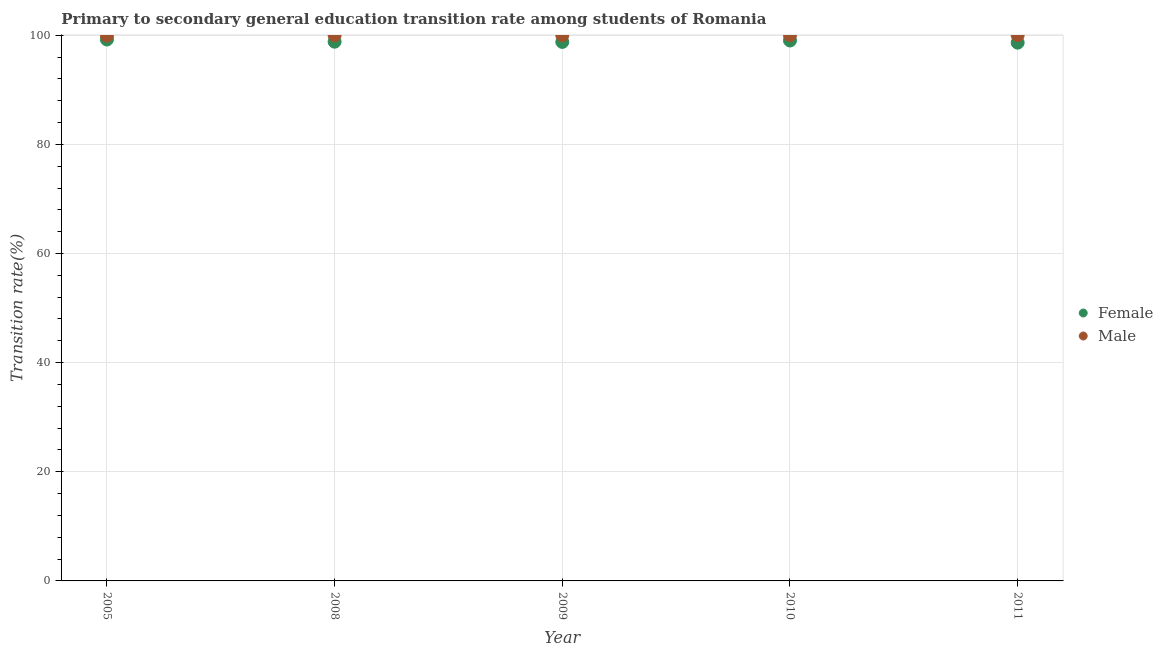How many different coloured dotlines are there?
Your answer should be very brief. 2. Across all years, what is the minimum transition rate among female students?
Your answer should be compact. 98.64. In which year was the transition rate among male students maximum?
Provide a short and direct response. 2008. What is the total transition rate among male students in the graph?
Provide a short and direct response. 499.93. What is the difference between the transition rate among female students in 2008 and that in 2011?
Provide a succinct answer. 0.18. What is the difference between the transition rate among female students in 2011 and the transition rate among male students in 2009?
Your answer should be very brief. -1.36. What is the average transition rate among male students per year?
Your response must be concise. 99.99. In the year 2011, what is the difference between the transition rate among male students and transition rate among female students?
Offer a very short reply. 1.36. In how many years, is the transition rate among female students greater than 16 %?
Make the answer very short. 5. What is the ratio of the transition rate among male students in 2005 to that in 2008?
Give a very brief answer. 1. Is the transition rate among male students in 2005 less than that in 2011?
Make the answer very short. Yes. What is the difference between the highest and the lowest transition rate among male students?
Make the answer very short. 0.07. In how many years, is the transition rate among female students greater than the average transition rate among female students taken over all years?
Your answer should be very brief. 2. Is the sum of the transition rate among male students in 2005 and 2008 greater than the maximum transition rate among female students across all years?
Offer a terse response. Yes. Is the transition rate among female students strictly greater than the transition rate among male students over the years?
Your answer should be compact. No. Is the transition rate among female students strictly less than the transition rate among male students over the years?
Keep it short and to the point. Yes. How many dotlines are there?
Offer a terse response. 2. What is the difference between two consecutive major ticks on the Y-axis?
Offer a terse response. 20. Where does the legend appear in the graph?
Your response must be concise. Center right. How are the legend labels stacked?
Provide a succinct answer. Vertical. What is the title of the graph?
Ensure brevity in your answer.  Primary to secondary general education transition rate among students of Romania. What is the label or title of the X-axis?
Ensure brevity in your answer.  Year. What is the label or title of the Y-axis?
Offer a very short reply. Transition rate(%). What is the Transition rate(%) of Female in 2005?
Your answer should be very brief. 99.22. What is the Transition rate(%) of Male in 2005?
Your answer should be very brief. 99.93. What is the Transition rate(%) of Female in 2008?
Make the answer very short. 98.82. What is the Transition rate(%) of Female in 2009?
Your response must be concise. 98.78. What is the Transition rate(%) of Male in 2009?
Your answer should be very brief. 100. What is the Transition rate(%) in Female in 2010?
Offer a terse response. 99.04. What is the Transition rate(%) in Male in 2010?
Offer a terse response. 100. What is the Transition rate(%) in Female in 2011?
Your response must be concise. 98.64. What is the Transition rate(%) in Male in 2011?
Provide a succinct answer. 100. Across all years, what is the maximum Transition rate(%) of Female?
Offer a terse response. 99.22. Across all years, what is the maximum Transition rate(%) in Male?
Your answer should be compact. 100. Across all years, what is the minimum Transition rate(%) in Female?
Your response must be concise. 98.64. Across all years, what is the minimum Transition rate(%) in Male?
Offer a very short reply. 99.93. What is the total Transition rate(%) in Female in the graph?
Your answer should be compact. 494.51. What is the total Transition rate(%) in Male in the graph?
Offer a very short reply. 499.93. What is the difference between the Transition rate(%) in Female in 2005 and that in 2008?
Your answer should be very brief. 0.4. What is the difference between the Transition rate(%) in Male in 2005 and that in 2008?
Provide a short and direct response. -0.07. What is the difference between the Transition rate(%) in Female in 2005 and that in 2009?
Your answer should be very brief. 0.44. What is the difference between the Transition rate(%) in Male in 2005 and that in 2009?
Offer a very short reply. -0.07. What is the difference between the Transition rate(%) in Female in 2005 and that in 2010?
Your response must be concise. 0.18. What is the difference between the Transition rate(%) of Male in 2005 and that in 2010?
Offer a very short reply. -0.07. What is the difference between the Transition rate(%) of Female in 2005 and that in 2011?
Make the answer very short. 0.58. What is the difference between the Transition rate(%) in Male in 2005 and that in 2011?
Make the answer very short. -0.07. What is the difference between the Transition rate(%) in Female in 2008 and that in 2009?
Give a very brief answer. 0.04. What is the difference between the Transition rate(%) in Female in 2008 and that in 2010?
Your answer should be compact. -0.22. What is the difference between the Transition rate(%) of Female in 2008 and that in 2011?
Offer a very short reply. 0.18. What is the difference between the Transition rate(%) of Male in 2008 and that in 2011?
Ensure brevity in your answer.  0. What is the difference between the Transition rate(%) of Female in 2009 and that in 2010?
Offer a very short reply. -0.26. What is the difference between the Transition rate(%) in Male in 2009 and that in 2010?
Your answer should be compact. 0. What is the difference between the Transition rate(%) of Female in 2009 and that in 2011?
Your answer should be compact. 0.13. What is the difference between the Transition rate(%) in Female in 2010 and that in 2011?
Your response must be concise. 0.39. What is the difference between the Transition rate(%) of Female in 2005 and the Transition rate(%) of Male in 2008?
Your response must be concise. -0.78. What is the difference between the Transition rate(%) of Female in 2005 and the Transition rate(%) of Male in 2009?
Offer a very short reply. -0.78. What is the difference between the Transition rate(%) in Female in 2005 and the Transition rate(%) in Male in 2010?
Keep it short and to the point. -0.78. What is the difference between the Transition rate(%) in Female in 2005 and the Transition rate(%) in Male in 2011?
Offer a terse response. -0.78. What is the difference between the Transition rate(%) in Female in 2008 and the Transition rate(%) in Male in 2009?
Offer a very short reply. -1.18. What is the difference between the Transition rate(%) of Female in 2008 and the Transition rate(%) of Male in 2010?
Your response must be concise. -1.18. What is the difference between the Transition rate(%) of Female in 2008 and the Transition rate(%) of Male in 2011?
Provide a succinct answer. -1.18. What is the difference between the Transition rate(%) of Female in 2009 and the Transition rate(%) of Male in 2010?
Make the answer very short. -1.22. What is the difference between the Transition rate(%) in Female in 2009 and the Transition rate(%) in Male in 2011?
Offer a terse response. -1.22. What is the difference between the Transition rate(%) of Female in 2010 and the Transition rate(%) of Male in 2011?
Offer a very short reply. -0.96. What is the average Transition rate(%) in Female per year?
Ensure brevity in your answer.  98.9. What is the average Transition rate(%) of Male per year?
Keep it short and to the point. 99.99. In the year 2005, what is the difference between the Transition rate(%) in Female and Transition rate(%) in Male?
Provide a short and direct response. -0.71. In the year 2008, what is the difference between the Transition rate(%) of Female and Transition rate(%) of Male?
Give a very brief answer. -1.18. In the year 2009, what is the difference between the Transition rate(%) in Female and Transition rate(%) in Male?
Make the answer very short. -1.22. In the year 2010, what is the difference between the Transition rate(%) of Female and Transition rate(%) of Male?
Your answer should be very brief. -0.96. In the year 2011, what is the difference between the Transition rate(%) of Female and Transition rate(%) of Male?
Keep it short and to the point. -1.36. What is the ratio of the Transition rate(%) of Female in 2005 to that in 2008?
Offer a terse response. 1. What is the ratio of the Transition rate(%) in Male in 2005 to that in 2008?
Offer a terse response. 1. What is the ratio of the Transition rate(%) of Male in 2005 to that in 2010?
Offer a terse response. 1. What is the ratio of the Transition rate(%) in Female in 2005 to that in 2011?
Provide a succinct answer. 1.01. What is the ratio of the Transition rate(%) in Male in 2008 to that in 2010?
Keep it short and to the point. 1. What is the ratio of the Transition rate(%) in Male in 2009 to that in 2010?
Offer a terse response. 1. What is the ratio of the Transition rate(%) in Male in 2009 to that in 2011?
Your answer should be very brief. 1. What is the ratio of the Transition rate(%) in Female in 2010 to that in 2011?
Your answer should be compact. 1. What is the difference between the highest and the second highest Transition rate(%) of Female?
Offer a very short reply. 0.18. What is the difference between the highest and the second highest Transition rate(%) of Male?
Give a very brief answer. 0. What is the difference between the highest and the lowest Transition rate(%) of Female?
Make the answer very short. 0.58. What is the difference between the highest and the lowest Transition rate(%) of Male?
Keep it short and to the point. 0.07. 